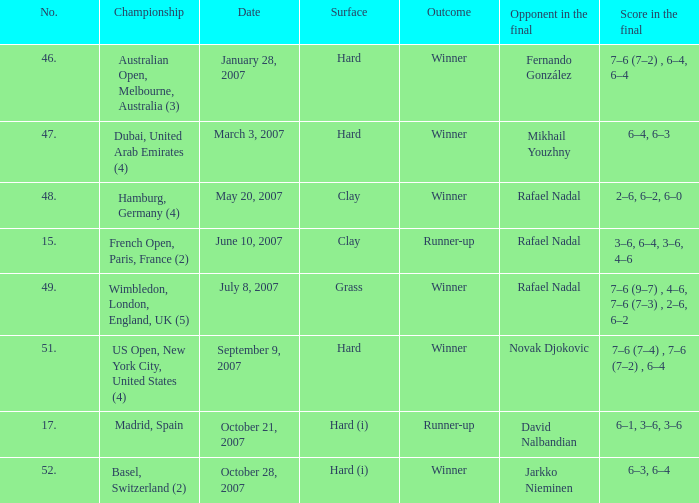The score in the final is 2–6, 6–2, 6–0, on what surface? Clay. 